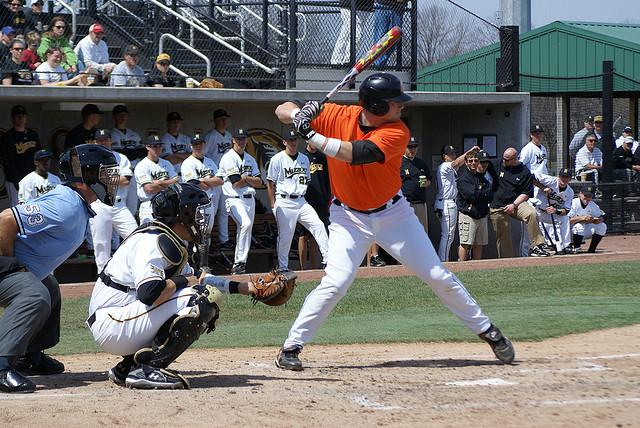What is the brown object in the squatting man's hand?

Choices:
A) football
B) resin
C) glove
D) pretzel glove 